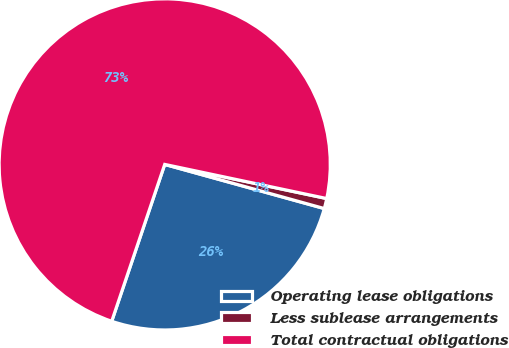Convert chart. <chart><loc_0><loc_0><loc_500><loc_500><pie_chart><fcel>Operating lease obligations<fcel>Less sublease arrangements<fcel>Total contractual obligations<nl><fcel>25.89%<fcel>0.99%<fcel>73.12%<nl></chart> 